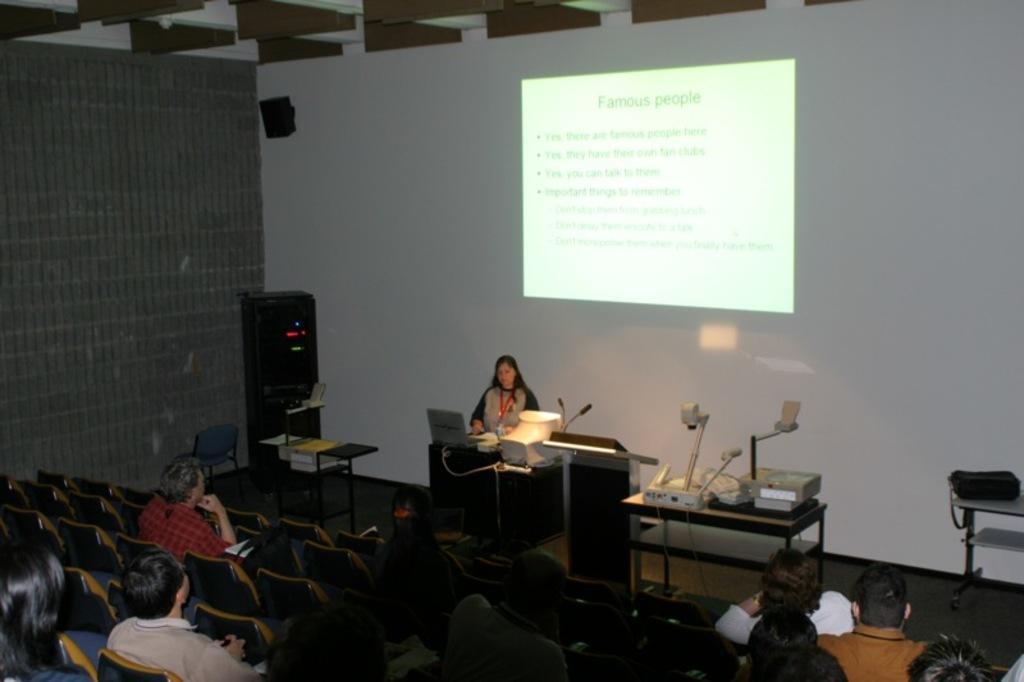In one or two sentences, can you explain what this image depicts? In the image there is a lady in the front using a laptop and background its screen and in front many people sat on chairs looking at the screen. 